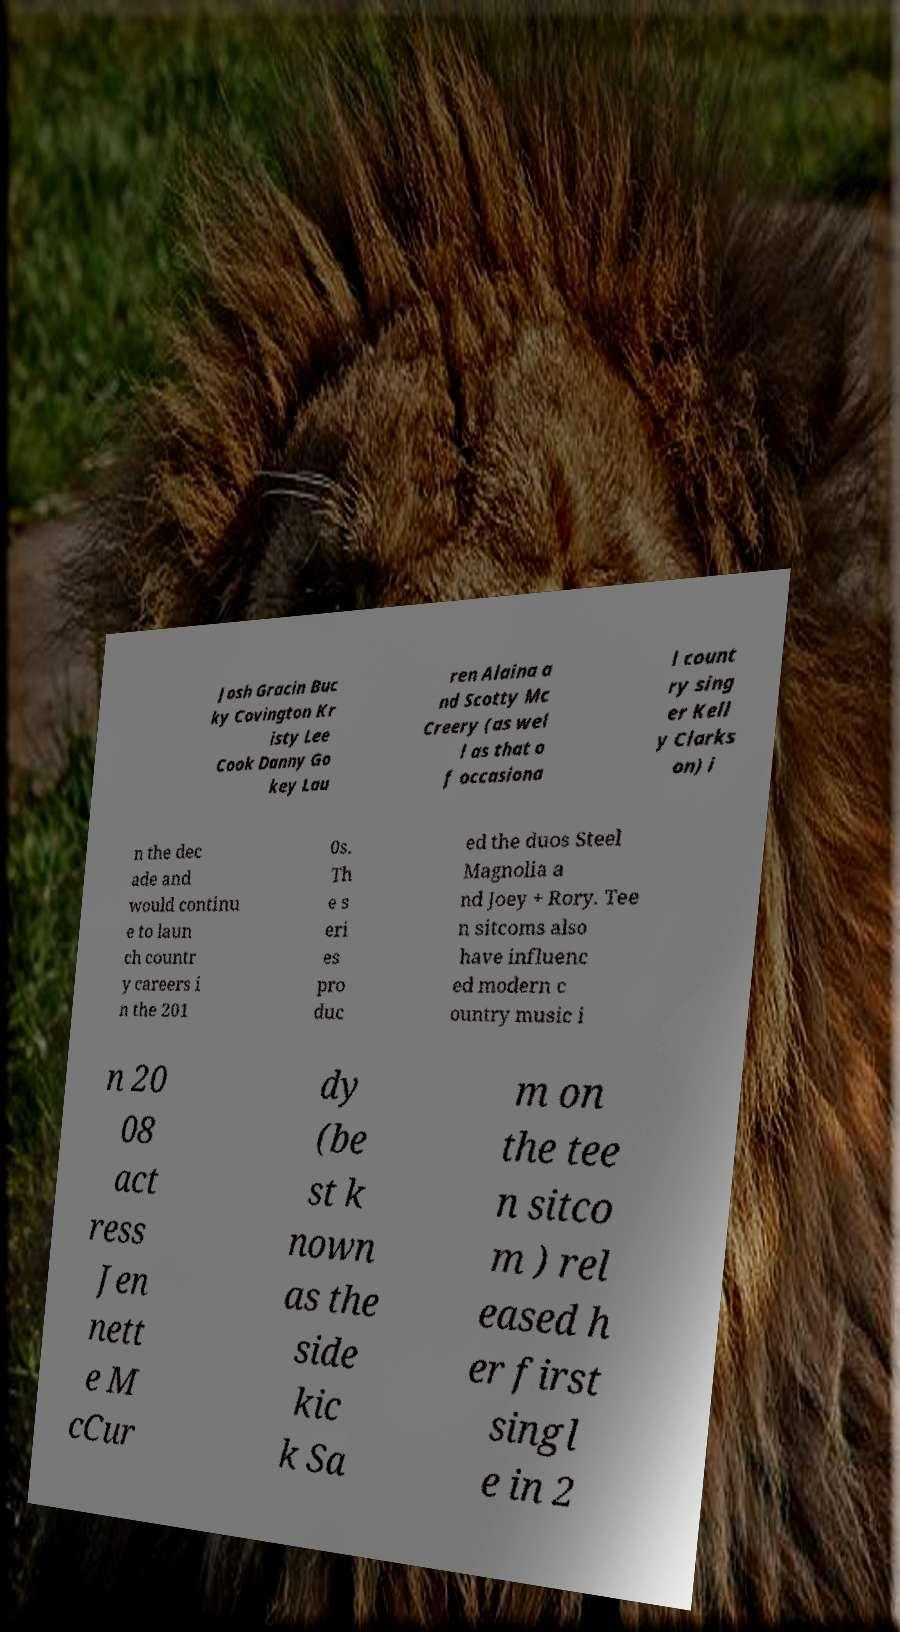Could you assist in decoding the text presented in this image and type it out clearly? Josh Gracin Buc ky Covington Kr isty Lee Cook Danny Go key Lau ren Alaina a nd Scotty Mc Creery (as wel l as that o f occasiona l count ry sing er Kell y Clarks on) i n the dec ade and would continu e to laun ch countr y careers i n the 201 0s. Th e s eri es pro duc ed the duos Steel Magnolia a nd Joey + Rory. Tee n sitcoms also have influenc ed modern c ountry music i n 20 08 act ress Jen nett e M cCur dy (be st k nown as the side kic k Sa m on the tee n sitco m ) rel eased h er first singl e in 2 